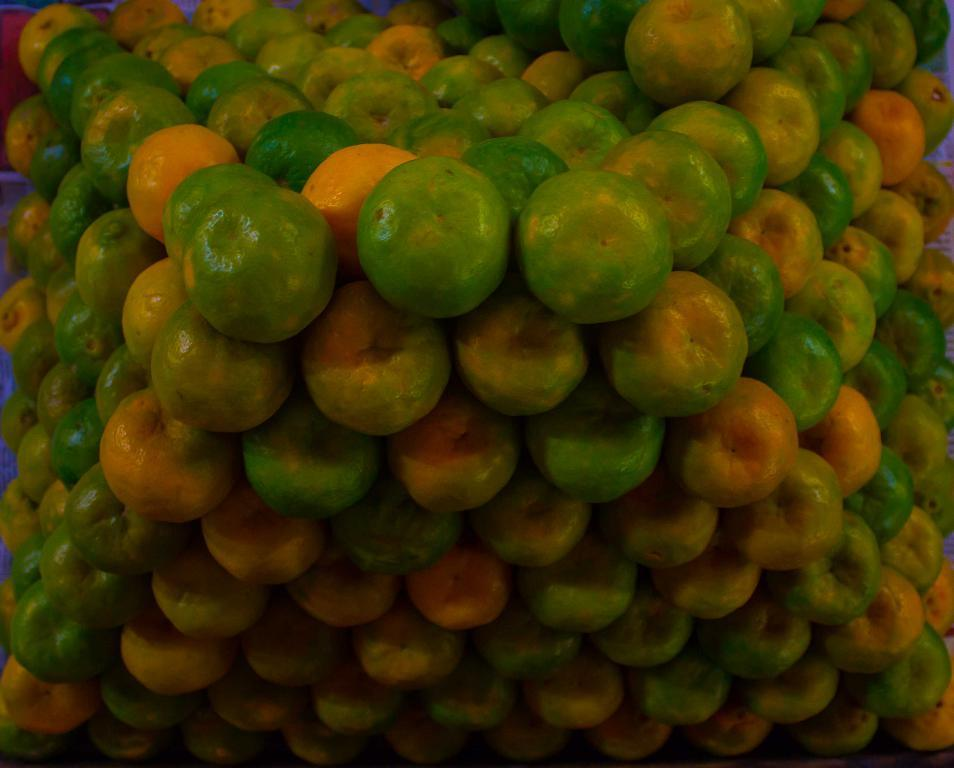What type of objects are arranged in a sequence manner in the image? There are fruits arranged in a sequence manner in the image. Can you identify the specific type of fruit in the image? Yes, the fruits in the image are oranges. What type of expert is standing next to the oranges in the image? There is no expert present in the image; it only features oranges arranged in a sequence manner. Where can you purchase these oranges in the image? The image does not show a store or any indication of where the oranges can be purchased. 